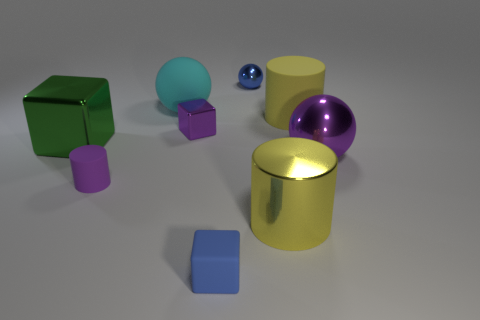Are the tiny block behind the large purple sphere and the large purple object made of the same material? Based on the image, it's challenging to conclusively determine if the tiny block and the large purple sphere are made of the same material solely by visual inspection. Materials can have similar visual properties like color and sheen yet differ substantially in texture, density, and composition. If we are discussing virtual objects in a computer-generated image, the appearance of being made from the same material might be a result of similar rendering settings rather than actual material properties. 